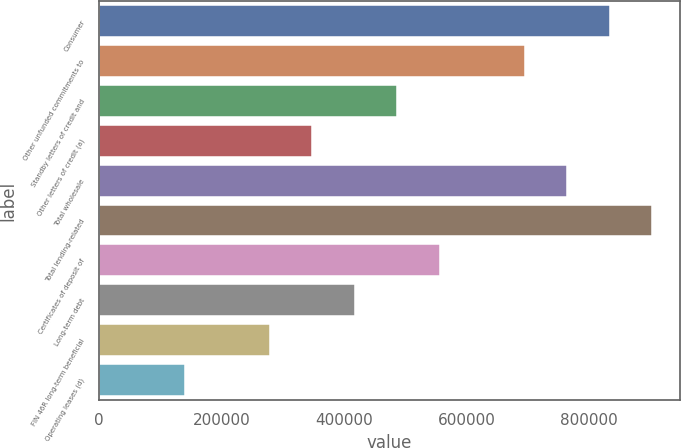Convert chart to OTSL. <chart><loc_0><loc_0><loc_500><loc_500><bar_chart><fcel>Consumer<fcel>Other unfunded commitments to<fcel>Standby letters of credit and<fcel>Other letters of credit (a)<fcel>Total wholesale<fcel>Total lending-related<fcel>Certificates of deposit of<fcel>Long-term debt<fcel>FIN 46R long-term beneficial<fcel>Operating leases (d)<nl><fcel>833489<fcel>694719<fcel>486564<fcel>347794<fcel>764104<fcel>902874<fcel>555949<fcel>417179<fcel>278408<fcel>139638<nl></chart> 